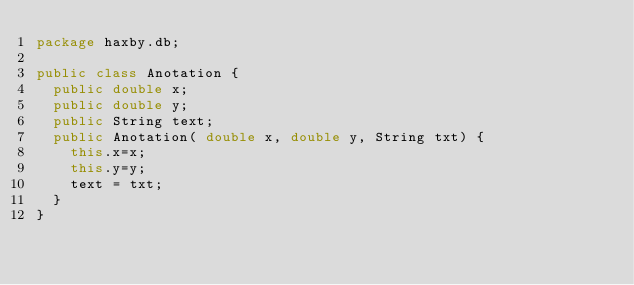<code> <loc_0><loc_0><loc_500><loc_500><_Java_>package haxby.db;

public class Anotation {
	public double x;
	public double y;
	public String text;
	public Anotation( double x, double y, String txt) {
		this.x=x;
		this.y=y;
		text = txt;
	}
}
</code> 